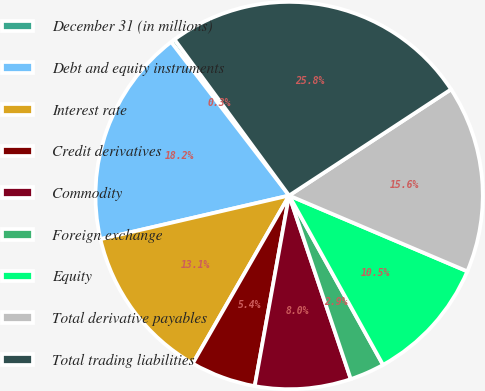Convert chart to OTSL. <chart><loc_0><loc_0><loc_500><loc_500><pie_chart><fcel>December 31 (in millions)<fcel>Debt and equity instruments<fcel>Interest rate<fcel>Credit derivatives<fcel>Commodity<fcel>Foreign exchange<fcel>Equity<fcel>Total derivative payables<fcel>Total trading liabilities<nl><fcel>0.35%<fcel>18.19%<fcel>13.09%<fcel>5.45%<fcel>8.0%<fcel>2.9%<fcel>10.54%<fcel>15.64%<fcel>25.84%<nl></chart> 